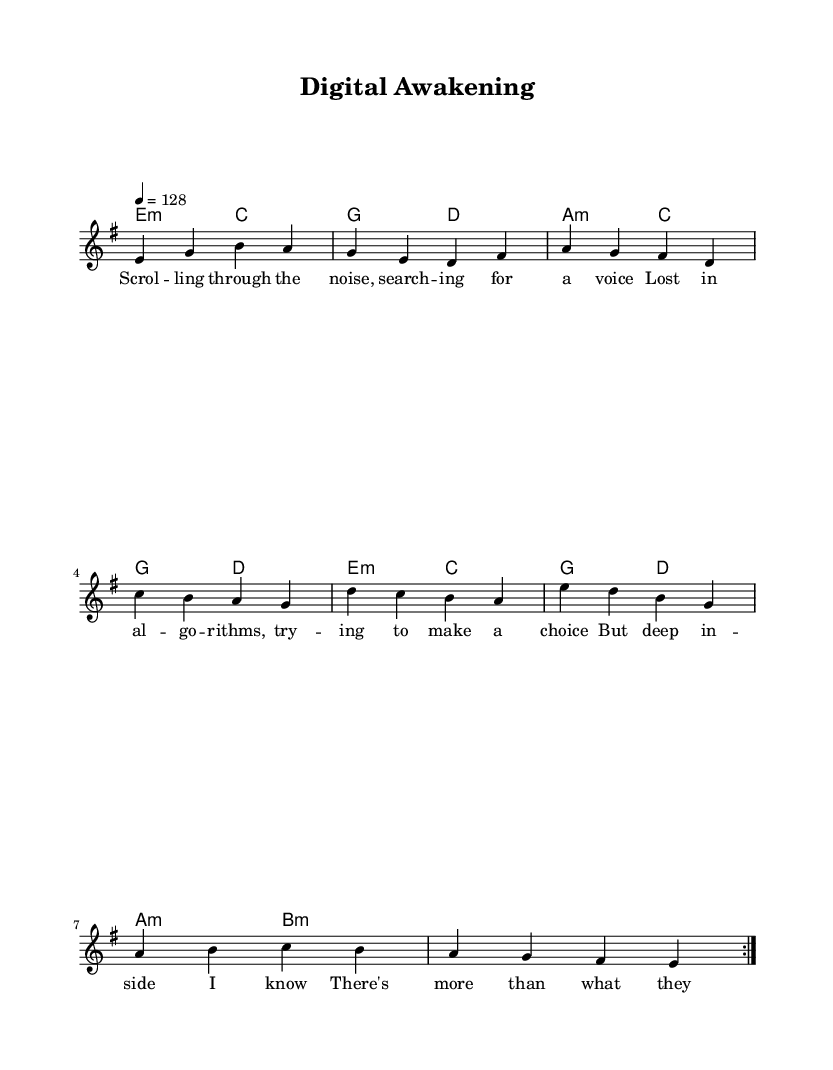What is the key signature of this music? The key signature is indicated by the "key" command in the global variable, which shows E minor has one sharp.
Answer: E minor What is the time signature of this music? The time signature is specified in the global variable under "time," showing a 4/4 meter, meaning there are four beats per measure.
Answer: 4/4 What is the tempo marking in this sheet music? The tempo marking appears in the global variable, where "tempo 4 = 128" indicates the beats per minute.
Answer: 128 How many measures are repeated in the melody section? The melody section includes the command "\repeat volta 2," indicating that the measures within this section are repeated twice.
Answer: 2 What is the first lyric line of the verse? The line of lyrics can be found in the "verse" section, where it begins with "Scrolling through the noise..." showing the first phrase.
Answer: Scrolling through the noise What chords are played during the chorus section? The chords can be traced from the "harmonies" section, which indicates the chords present, specifically during the chorus part. The chords listed for the chorus are E minor, C, A minor, G, and D.
Answer: E minor, C, A minor, G, D What two concepts are juxtaposed in the song's theme? The song's lyrics and overall theme can be interpreted from the verses and chorus, revolving around youth's struggle with technology and self-discovery. The juxtaposition is notably between the digital world and personal awakening.
Answer: Digital struggle and self-discovery 